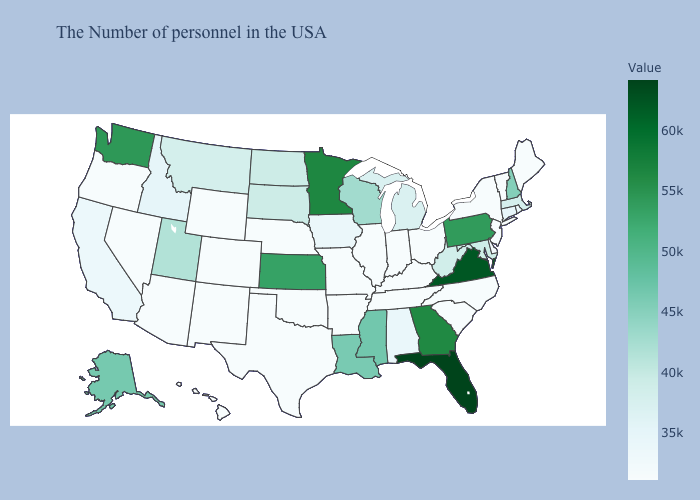Among the states that border Rhode Island , which have the lowest value?
Quick response, please. Connecticut. Does New Jersey have the lowest value in the Northeast?
Be succinct. Yes. Does South Dakota have a lower value than Missouri?
Answer briefly. No. Which states have the highest value in the USA?
Be succinct. Florida. 